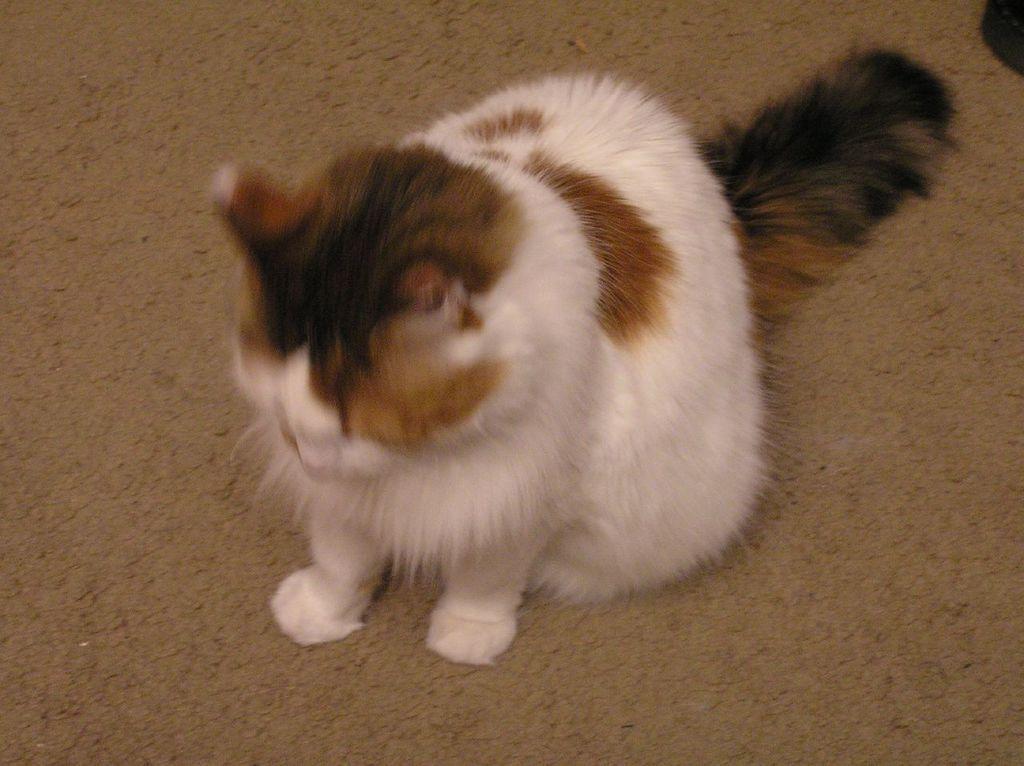In one or two sentences, can you explain what this image depicts? In this image, we can see a cat on the ground. We can also see some object in the top right corner. 